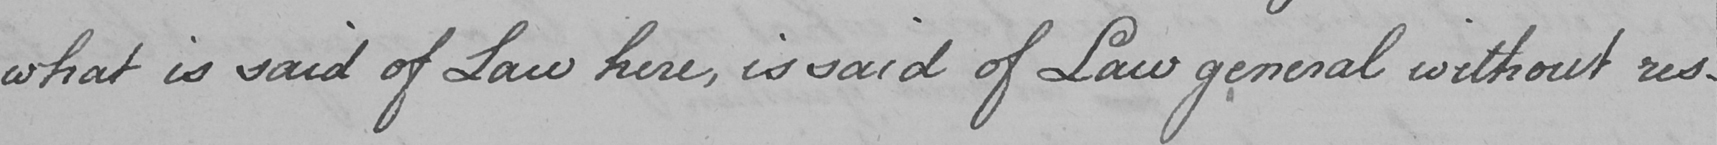Please transcribe the handwritten text in this image. what is said of Law here , is said of Law general without res- 